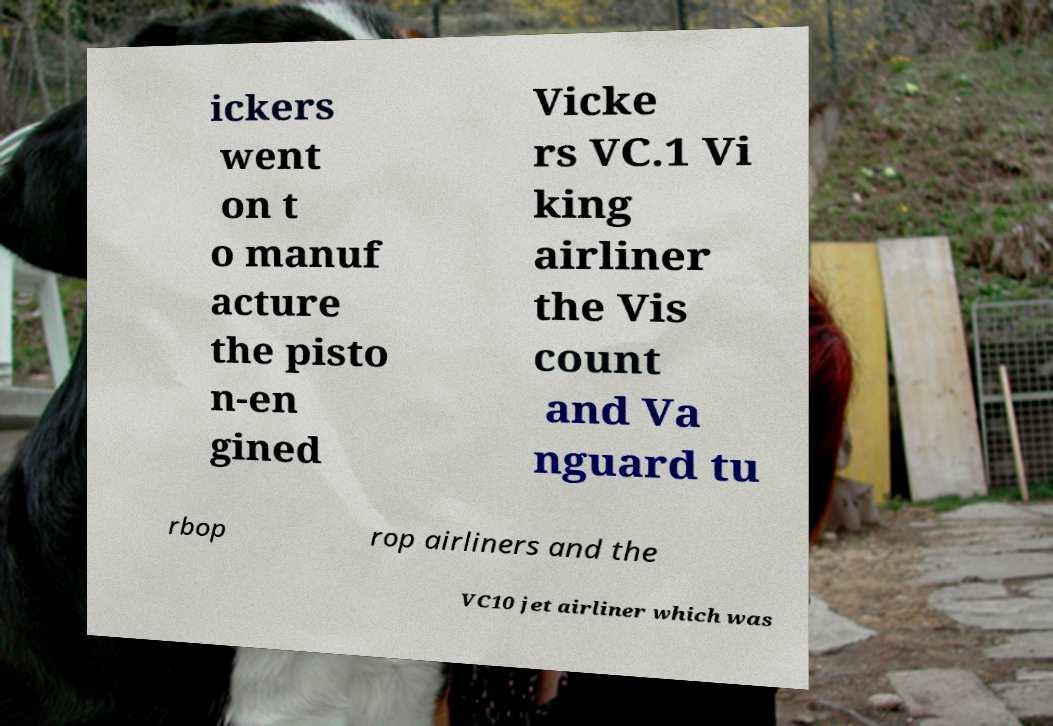What messages or text are displayed in this image? I need them in a readable, typed format. ickers went on t o manuf acture the pisto n-en gined Vicke rs VC.1 Vi king airliner the Vis count and Va nguard tu rbop rop airliners and the VC10 jet airliner which was 